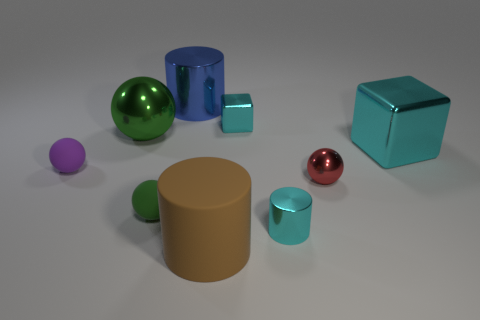Subtract all large cylinders. How many cylinders are left? 1 Add 1 tiny blocks. How many objects exist? 10 Subtract all blue cylinders. How many cylinders are left? 2 Subtract all cylinders. How many objects are left? 6 Subtract all purple spheres. How many purple cylinders are left? 0 Add 4 big brown cylinders. How many big brown cylinders are left? 5 Add 2 large cyan things. How many large cyan things exist? 3 Subtract 0 purple cubes. How many objects are left? 9 Subtract 3 cylinders. How many cylinders are left? 0 Subtract all purple cylinders. Subtract all yellow spheres. How many cylinders are left? 3 